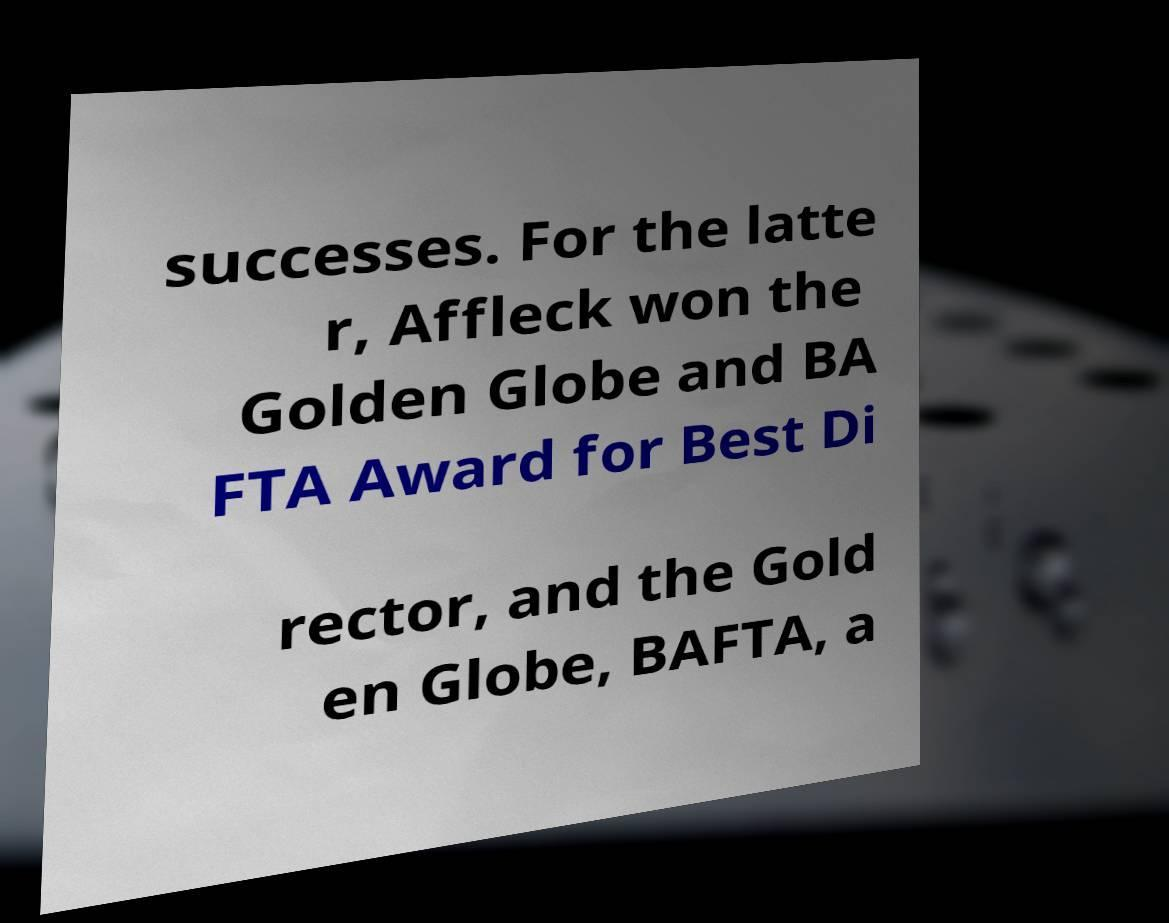Can you accurately transcribe the text from the provided image for me? successes. For the latte r, Affleck won the Golden Globe and BA FTA Award for Best Di rector, and the Gold en Globe, BAFTA, a 